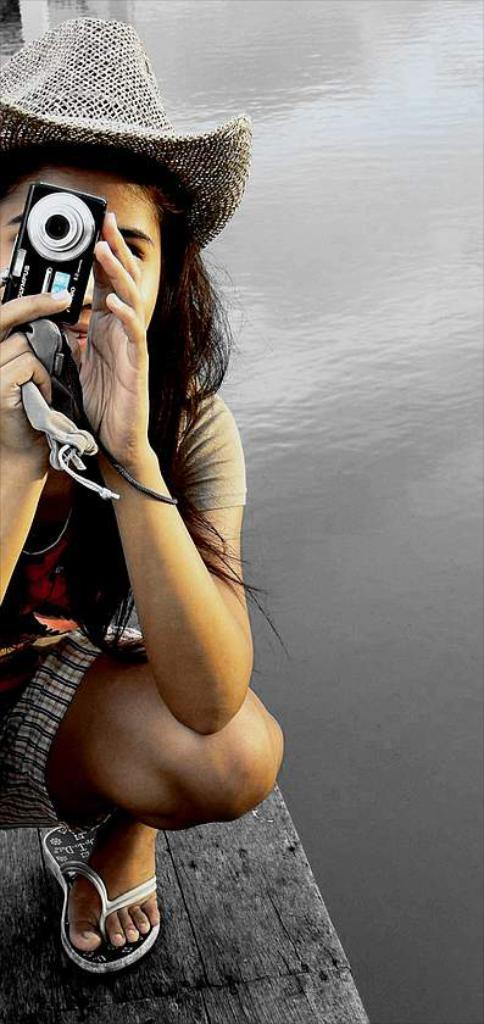Who is the main subject in the image? There is a woman in the image. What is the woman holding in her hands? The woman is holding a camera in her hands. What can be seen in the background of the image? There is water visible in the image. How many trains can be seen in the image? There are no trains present in the image. What type of breath is the woman taking in the image? There is no indication of the woman's breathing in the image. 